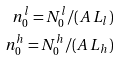Convert formula to latex. <formula><loc_0><loc_0><loc_500><loc_500>n ^ { l } _ { 0 } = N ^ { l } _ { 0 } / ( A \, L _ { l } ) \\ n ^ { h } _ { 0 } = N ^ { h } _ { 0 } / ( A \, L _ { h } )</formula> 